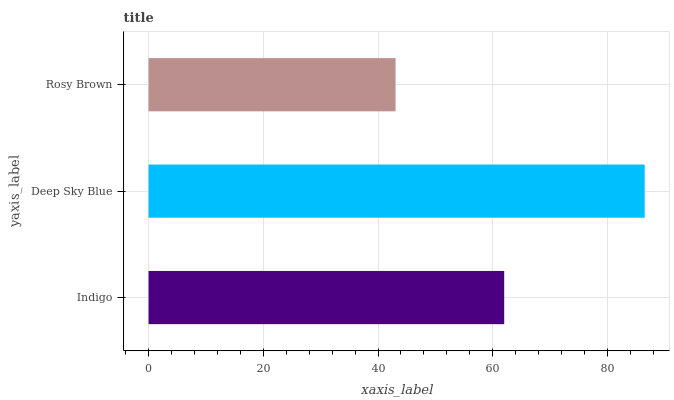Is Rosy Brown the minimum?
Answer yes or no. Yes. Is Deep Sky Blue the maximum?
Answer yes or no. Yes. Is Deep Sky Blue the minimum?
Answer yes or no. No. Is Rosy Brown the maximum?
Answer yes or no. No. Is Deep Sky Blue greater than Rosy Brown?
Answer yes or no. Yes. Is Rosy Brown less than Deep Sky Blue?
Answer yes or no. Yes. Is Rosy Brown greater than Deep Sky Blue?
Answer yes or no. No. Is Deep Sky Blue less than Rosy Brown?
Answer yes or no. No. Is Indigo the high median?
Answer yes or no. Yes. Is Indigo the low median?
Answer yes or no. Yes. Is Deep Sky Blue the high median?
Answer yes or no. No. Is Rosy Brown the low median?
Answer yes or no. No. 